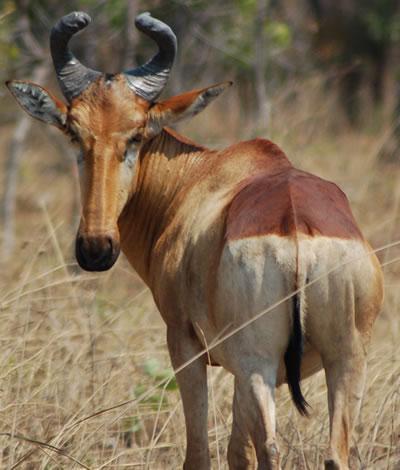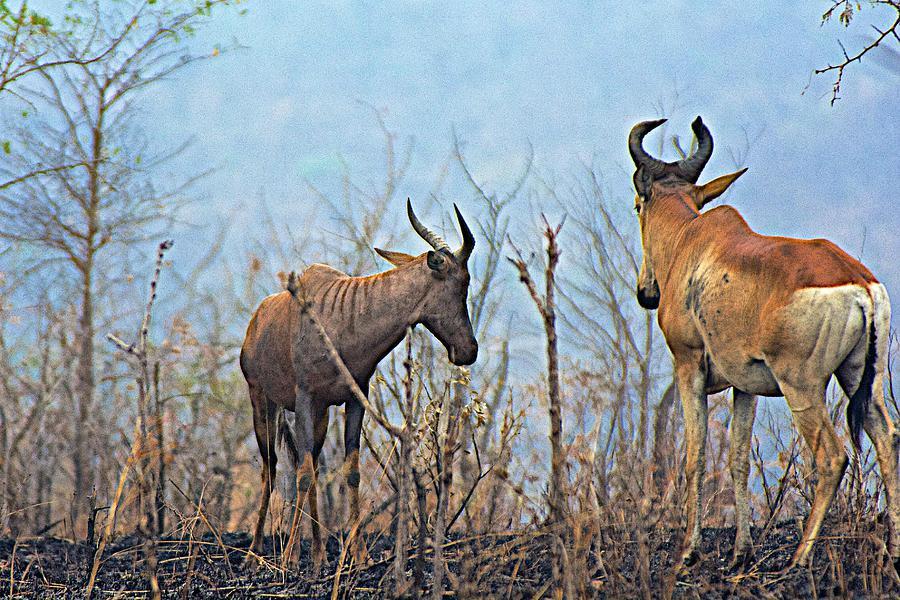The first image is the image on the left, the second image is the image on the right. Assess this claim about the two images: "One image contains at least three times the number of hooved animals as the other image.". Correct or not? Answer yes or no. No. The first image is the image on the left, the second image is the image on the right. Considering the images on both sides, is "One of the images has only one living creature." valid? Answer yes or no. Yes. 